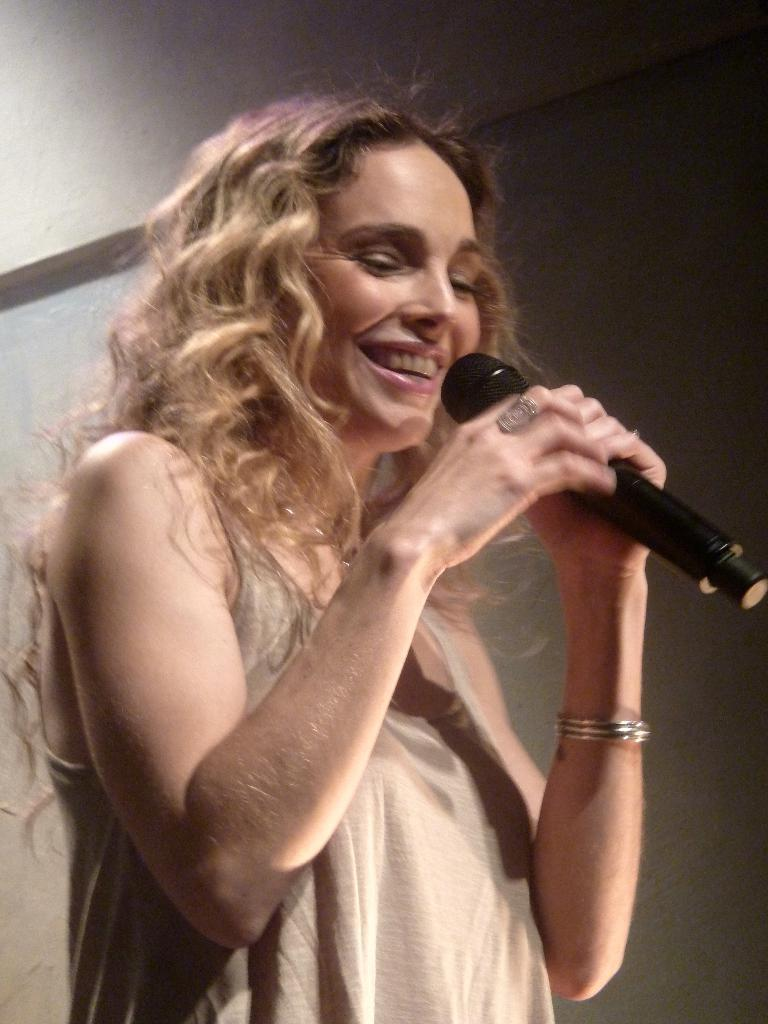Where was the image taken? The image was taken indoors. What can be seen in the background of the image? There is a wall in the background of the image. Who is the main subject in the image? There is a woman in the middle of the image. What is the woman's facial expression? The woman has a smiling face. What is the woman holding in her hands? The woman is holding a mic in her hands. Can you see a monkey holding a spoon in the hole in the image? There is no monkey, spoon, or hole present in the image. 